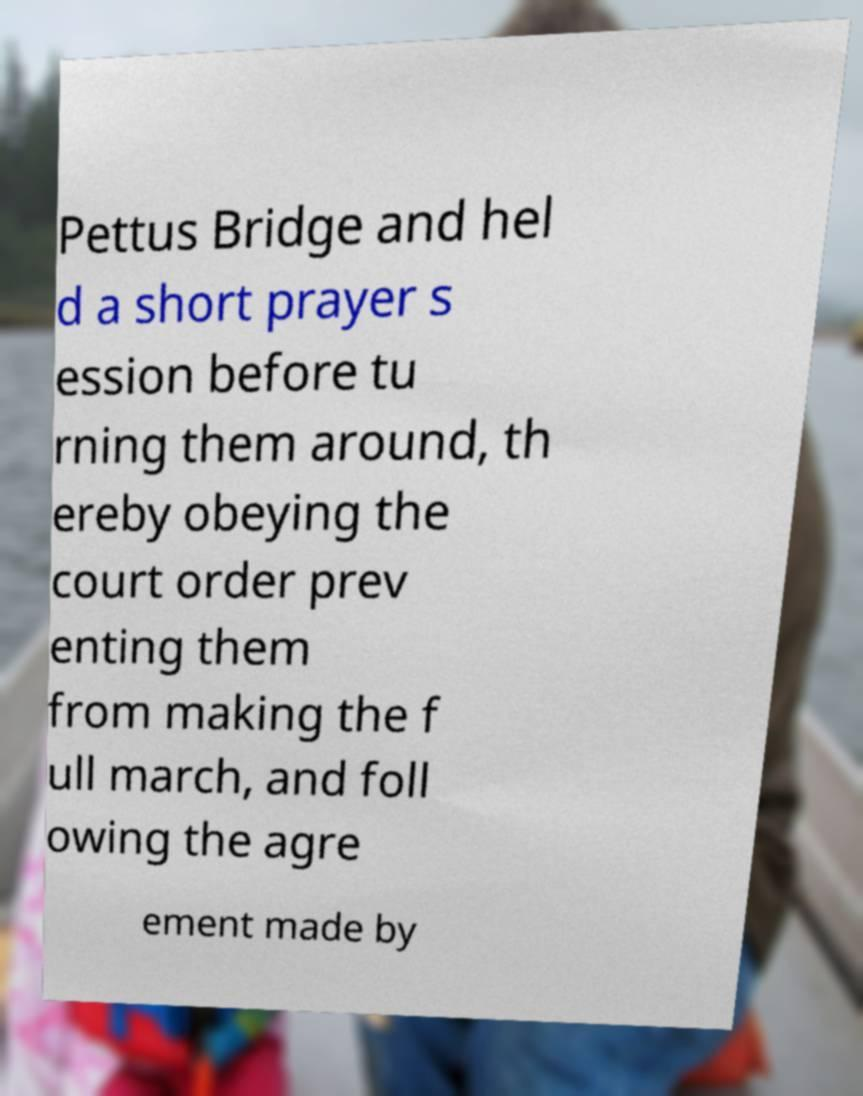Can you accurately transcribe the text from the provided image for me? Pettus Bridge and hel d a short prayer s ession before tu rning them around, th ereby obeying the court order prev enting them from making the f ull march, and foll owing the agre ement made by 